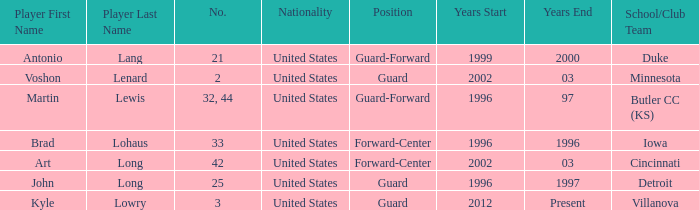What position does the player who played for butler cc (ks) play? Guard-Forward. 